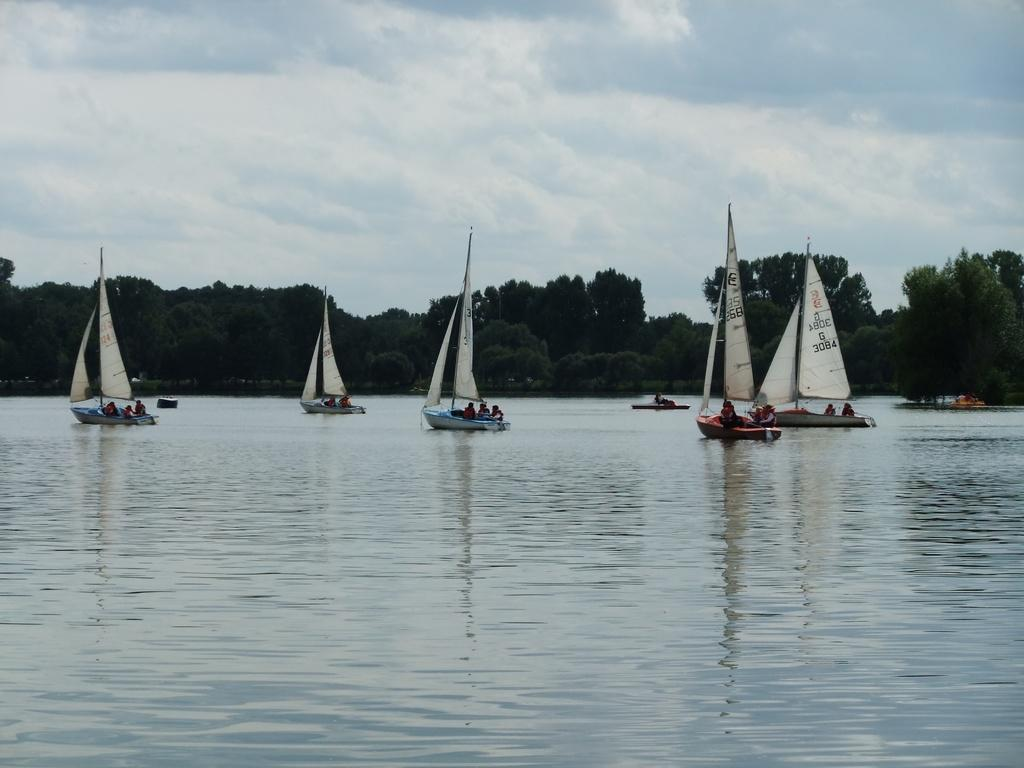What type of environment is depicted in the image? The image is an outside view. What can be seen at the bottom of the image? There is water visible at the bottom of the image. What is floating on the water? There are boats in the water. What can be seen in the background of the image? There are many trees in the background of the image. What is visible at the top of the image? The sky is visible at the top of the image. What can be observed in the sky? Clouds are present in the sky. What type of instrument is being played in the image? There is no instrument present in the image; it is an outside view of a water scene with boats and trees. What is the acoustics like in the image? The image does not depict a specific sound environment, so it is not possible to determine the acoustics. 